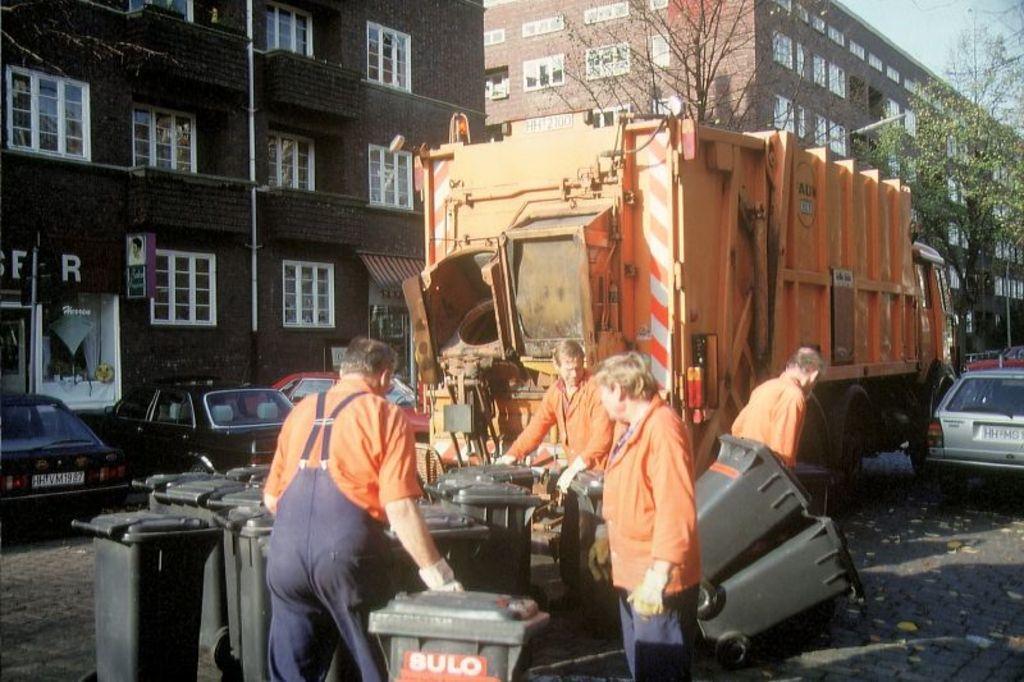Can you describe this image briefly? In the foreground of the picture I can see a few men standing on the road and they are holding the garbage boxes. I can see the cars parked on the side of the road. I can see the dump yard vehicle on the road. I can see the buildings and glass windows. There are trees on the side of the road on the top right side. 